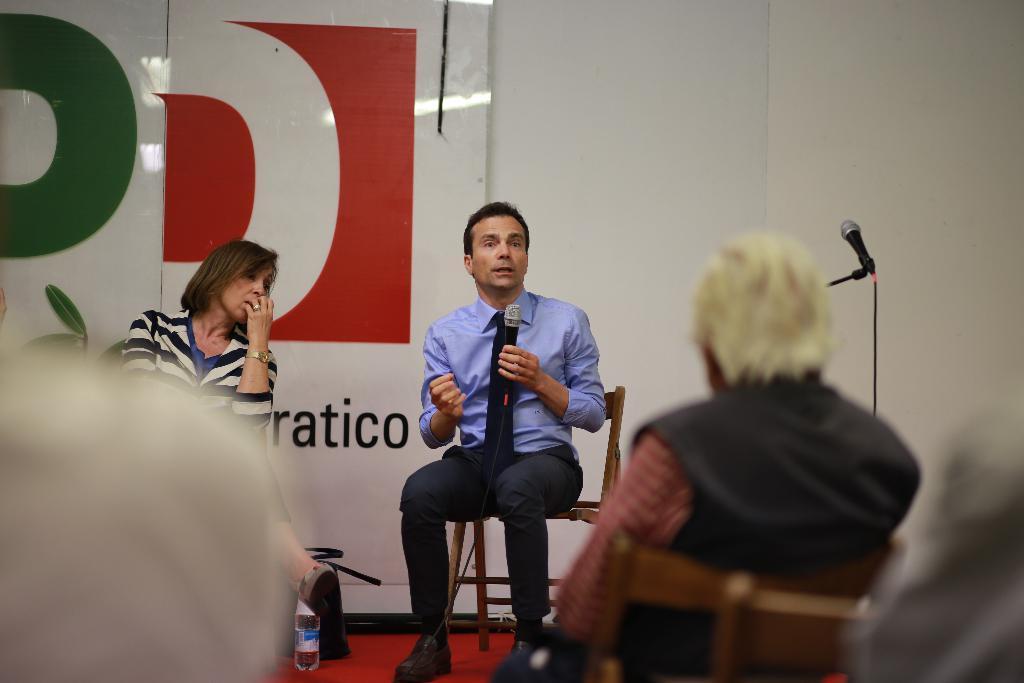Describe this image in one or two sentences. In the center of the image we can see a man sitting on the chair and holding a mic, next to him there is a lady sitting. At the bottom there are people and we can see a mic placed on the stand. In the background there is a board and a wall. 